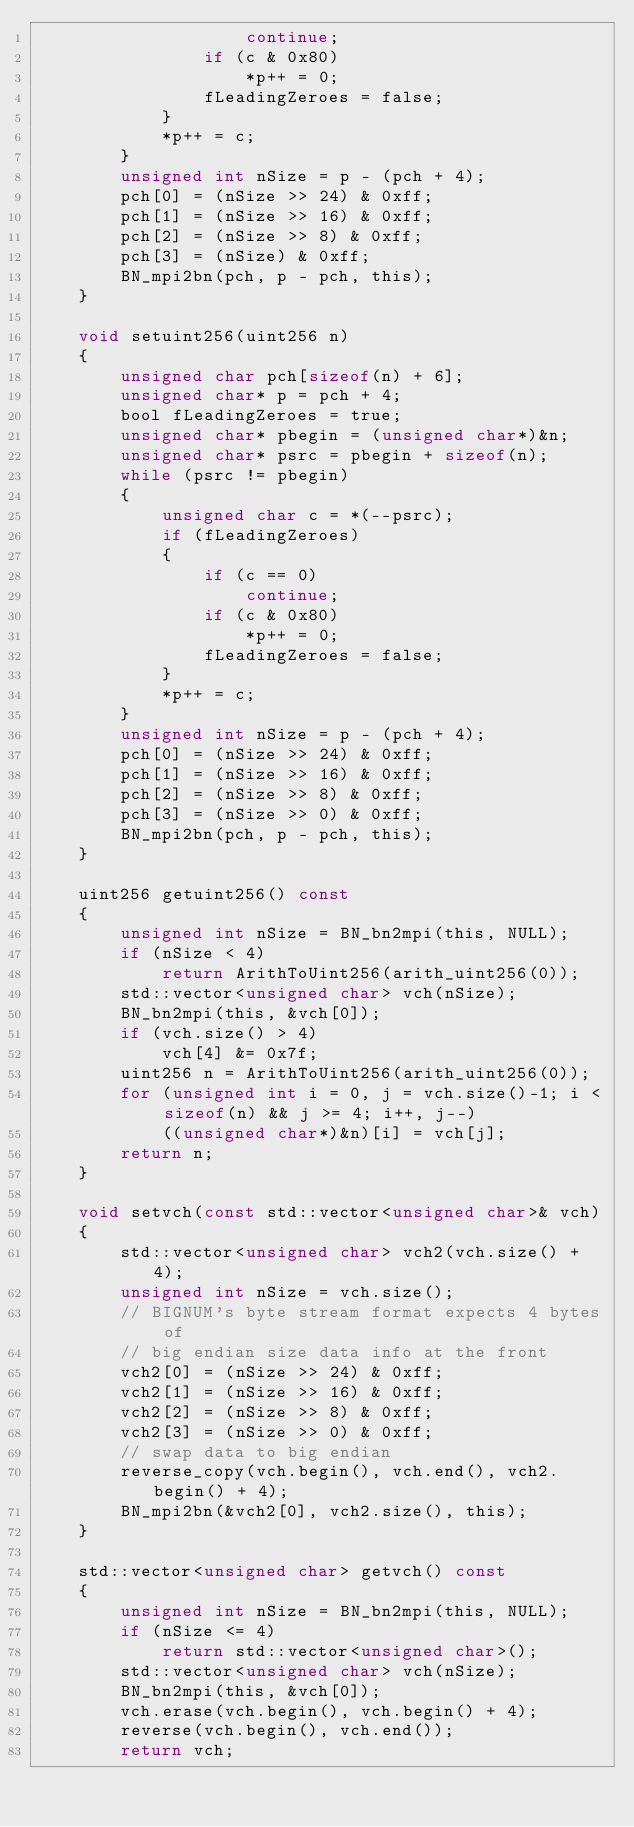Convert code to text. <code><loc_0><loc_0><loc_500><loc_500><_C_>                    continue;
                if (c & 0x80)
                    *p++ = 0;
                fLeadingZeroes = false;
            }
            *p++ = c;
        }
        unsigned int nSize = p - (pch + 4);
        pch[0] = (nSize >> 24) & 0xff;
        pch[1] = (nSize >> 16) & 0xff;
        pch[2] = (nSize >> 8) & 0xff;
        pch[3] = (nSize) & 0xff;
        BN_mpi2bn(pch, p - pch, this);
    }

    void setuint256(uint256 n)
    {
        unsigned char pch[sizeof(n) + 6];
        unsigned char* p = pch + 4;
        bool fLeadingZeroes = true;
        unsigned char* pbegin = (unsigned char*)&n;
        unsigned char* psrc = pbegin + sizeof(n);
        while (psrc != pbegin)
        {
            unsigned char c = *(--psrc);
            if (fLeadingZeroes)
            {
                if (c == 0)
                    continue;
                if (c & 0x80)
                    *p++ = 0;
                fLeadingZeroes = false;
            }
            *p++ = c;
        }
        unsigned int nSize = p - (pch + 4);
        pch[0] = (nSize >> 24) & 0xff;
        pch[1] = (nSize >> 16) & 0xff;
        pch[2] = (nSize >> 8) & 0xff;
        pch[3] = (nSize >> 0) & 0xff;
        BN_mpi2bn(pch, p - pch, this);
    }

    uint256 getuint256() const
    {
        unsigned int nSize = BN_bn2mpi(this, NULL);
        if (nSize < 4)
            return ArithToUint256(arith_uint256(0));
        std::vector<unsigned char> vch(nSize);
        BN_bn2mpi(this, &vch[0]);
        if (vch.size() > 4)
            vch[4] &= 0x7f;
        uint256 n = ArithToUint256(arith_uint256(0));
        for (unsigned int i = 0, j = vch.size()-1; i < sizeof(n) && j >= 4; i++, j--)
            ((unsigned char*)&n)[i] = vch[j];
        return n;
    }

    void setvch(const std::vector<unsigned char>& vch)
    {
        std::vector<unsigned char> vch2(vch.size() + 4);
        unsigned int nSize = vch.size();
        // BIGNUM's byte stream format expects 4 bytes of
        // big endian size data info at the front
        vch2[0] = (nSize >> 24) & 0xff;
        vch2[1] = (nSize >> 16) & 0xff;
        vch2[2] = (nSize >> 8) & 0xff;
        vch2[3] = (nSize >> 0) & 0xff;
        // swap data to big endian
        reverse_copy(vch.begin(), vch.end(), vch2.begin() + 4);
        BN_mpi2bn(&vch2[0], vch2.size(), this);
    }

    std::vector<unsigned char> getvch() const
    {
        unsigned int nSize = BN_bn2mpi(this, NULL);
        if (nSize <= 4)
            return std::vector<unsigned char>();
        std::vector<unsigned char> vch(nSize);
        BN_bn2mpi(this, &vch[0]);
        vch.erase(vch.begin(), vch.begin() + 4);
        reverse(vch.begin(), vch.end());
        return vch;</code> 